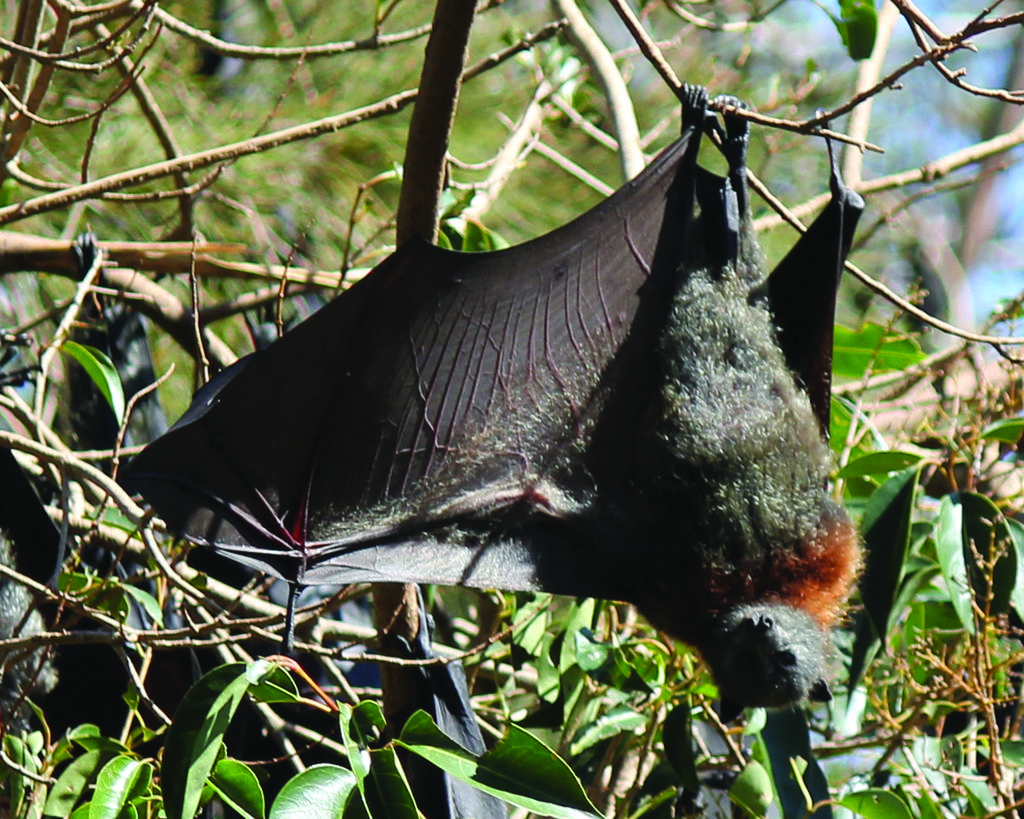What color are the leaves in the image? The leaves in the image are green. What type of animal can be seen in the image? There is a black color bird in the image. What is the bird holding in the image? The bird is holding a stem of a plant in the image. What else can be seen in the image besides the bird and leaves? There are stems of plants visible in the image. Can you see a goat playing with a wrench in the image? No, there is no goat or wrench present in the image. Is there a baseball game happening in the background of the image? No, there is no baseball game or any reference to sports in the image. 